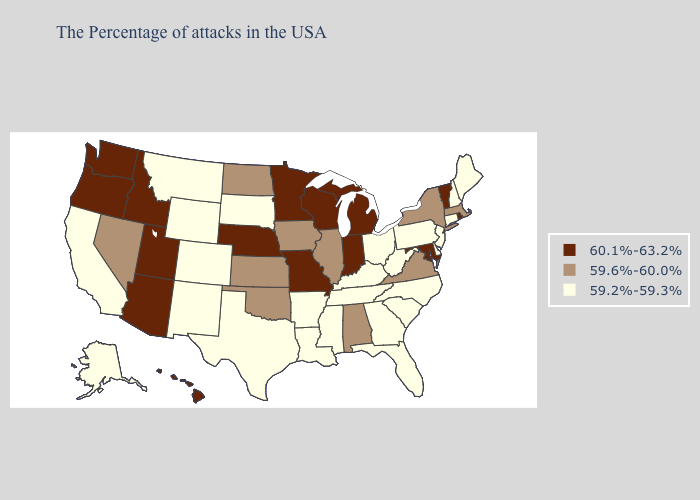Does Oklahoma have the highest value in the USA?
Be succinct. No. Does Ohio have the highest value in the MidWest?
Keep it brief. No. Does New Mexico have the lowest value in the USA?
Concise answer only. Yes. Name the states that have a value in the range 59.6%-60.0%?
Concise answer only. Massachusetts, New York, Virginia, Alabama, Illinois, Iowa, Kansas, Oklahoma, North Dakota, Nevada. Name the states that have a value in the range 59.2%-59.3%?
Be succinct. Maine, New Hampshire, Connecticut, New Jersey, Delaware, Pennsylvania, North Carolina, South Carolina, West Virginia, Ohio, Florida, Georgia, Kentucky, Tennessee, Mississippi, Louisiana, Arkansas, Texas, South Dakota, Wyoming, Colorado, New Mexico, Montana, California, Alaska. Does the first symbol in the legend represent the smallest category?
Answer briefly. No. Does Nebraska have the highest value in the USA?
Be succinct. Yes. Name the states that have a value in the range 59.6%-60.0%?
Answer briefly. Massachusetts, New York, Virginia, Alabama, Illinois, Iowa, Kansas, Oklahoma, North Dakota, Nevada. Name the states that have a value in the range 60.1%-63.2%?
Quick response, please. Rhode Island, Vermont, Maryland, Michigan, Indiana, Wisconsin, Missouri, Minnesota, Nebraska, Utah, Arizona, Idaho, Washington, Oregon, Hawaii. Does New Mexico have the lowest value in the West?
Keep it brief. Yes. Among the states that border Pennsylvania , which have the lowest value?
Answer briefly. New Jersey, Delaware, West Virginia, Ohio. What is the value of Idaho?
Quick response, please. 60.1%-63.2%. Which states have the highest value in the USA?
Short answer required. Rhode Island, Vermont, Maryland, Michigan, Indiana, Wisconsin, Missouri, Minnesota, Nebraska, Utah, Arizona, Idaho, Washington, Oregon, Hawaii. Name the states that have a value in the range 59.6%-60.0%?
Write a very short answer. Massachusetts, New York, Virginia, Alabama, Illinois, Iowa, Kansas, Oklahoma, North Dakota, Nevada. 